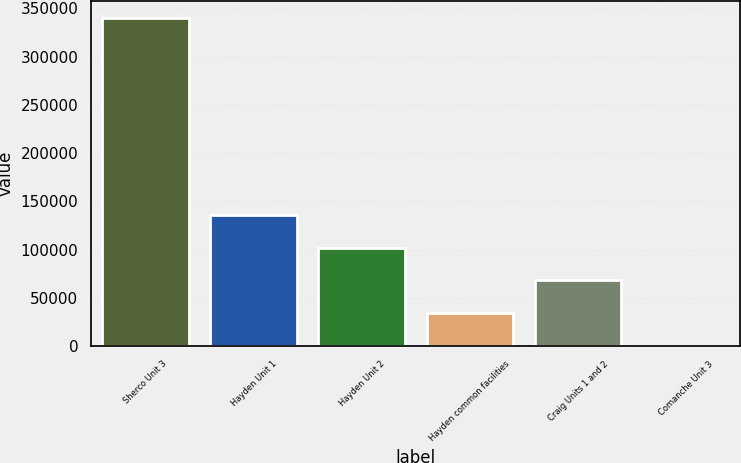Convert chart to OTSL. <chart><loc_0><loc_0><loc_500><loc_500><bar_chart><fcel>Sherco Unit 3<fcel>Hayden Unit 1<fcel>Hayden Unit 2<fcel>Hayden common facilities<fcel>Craig Units 1 and 2<fcel>Comanche Unit 3<nl><fcel>340258<fcel>136106<fcel>102080<fcel>34029.4<fcel>68054.8<fcel>4<nl></chart> 